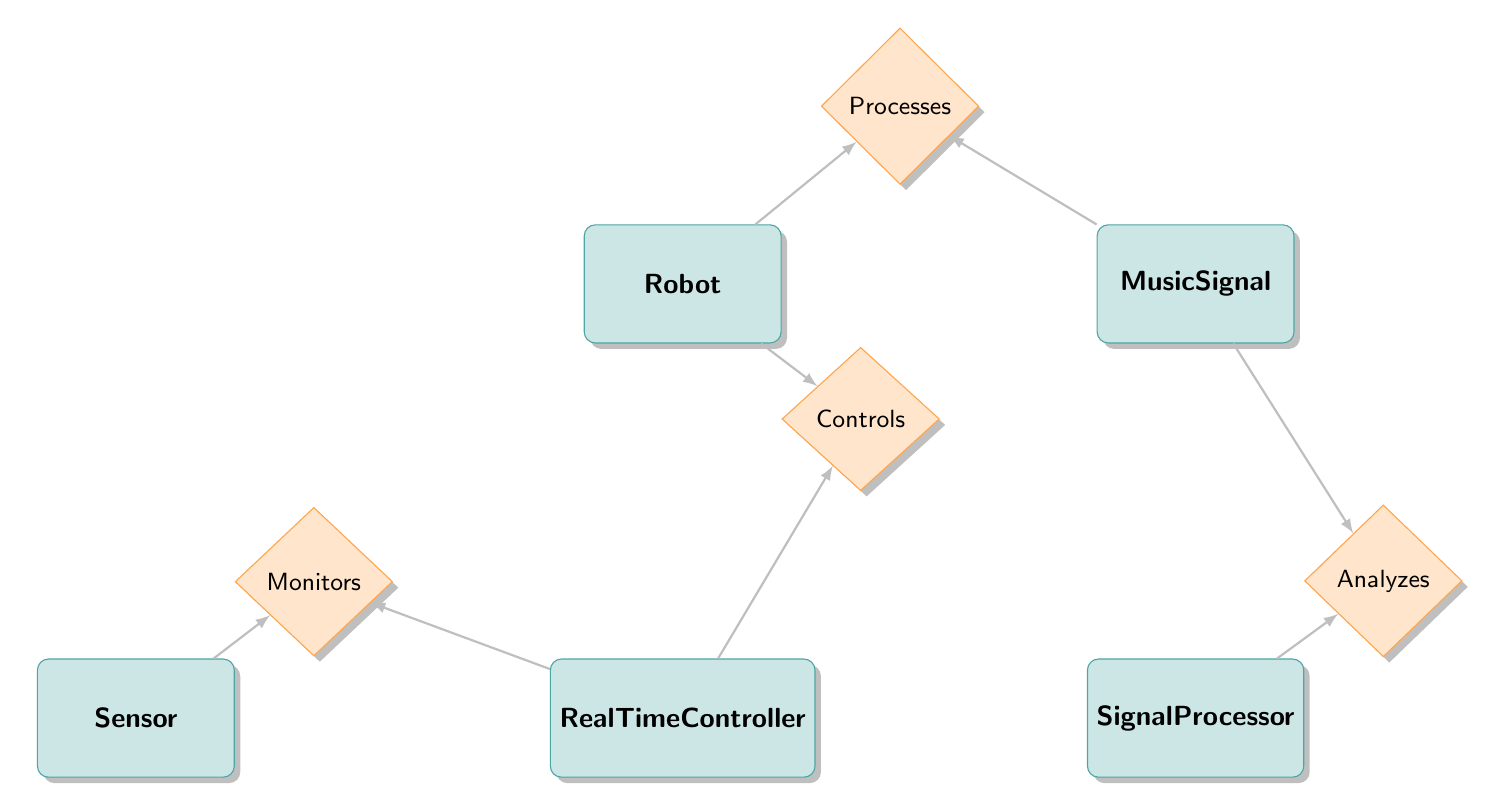What are the entities involved in this diagram? The diagram depicts five entities: Robot, MusicSignal, SignalProcessor, RealTimeController, and Sensor.
Answer: Robot, MusicSignal, SignalProcessor, RealTimeController, Sensor How many relationships are present in the diagram? There are four relationships connecting the entities: Processes, Controls, Monitors, and Analyzes.
Answer: Four Which entity has the most relationships? The Robot entity has two relationships, Processes and Controls, which connect it to both MusicSignal and RealTimeController, making it the entity with the most relationships.
Answer: Robot What relationship connects the SignalProcessor and MusicSignal? The relationship between SignalProcessor and MusicSignal is called Analyzes, indicating that the processor analyzes the musical signals.
Answer: Analyzes Which two entities are connected by the Monitors relationship? The Monitors relationship connects the entities Sensor and RealTimeController, suggesting that the sensor monitors the controller's operations.
Answer: Sensor and RealTimeController What attribute is unique to the RealTimeController entity? The RealTimeController entity has a unique attribute called response_time, which is essential for determining how quickly it reacts to the robot's operations.
Answer: response_time Which entities are directly linked to the Robot entity? The Robot entity is directly linked to the MusicSignal through the Processes relationship and to the RealTimeController via the Controls relationship.
Answer: MusicSignal, RealTimeController What does the Processes relationship signify between the Robot and MusicSignal? The Processes relationship indicates that the Robot processes the MusicSignal, managing the musical information for its operations.
Answer: Processes What type of data is collected by the Sensor entity? The Sensor entity collects sensor_data based on its type, resolution, and sampling_rate attributes, useful for monitoring the Robot's environment.
Answer: sensor_data 